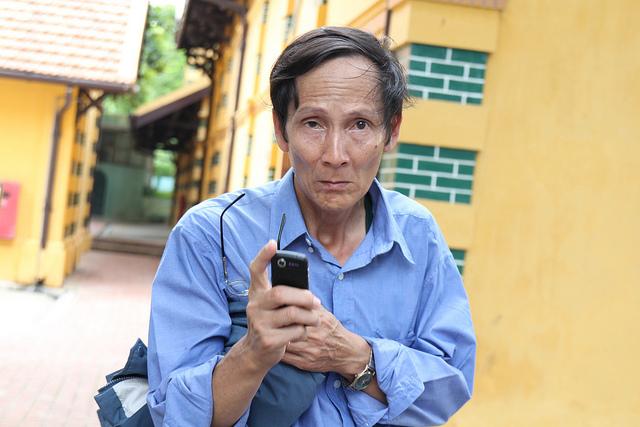Is the man satisfied?
Give a very brief answer. No. Did the shirt put itself on?
Answer briefly. No. Is he wearing a watch?
Be succinct. Yes. What color is his shirt?
Give a very brief answer. Blue. 